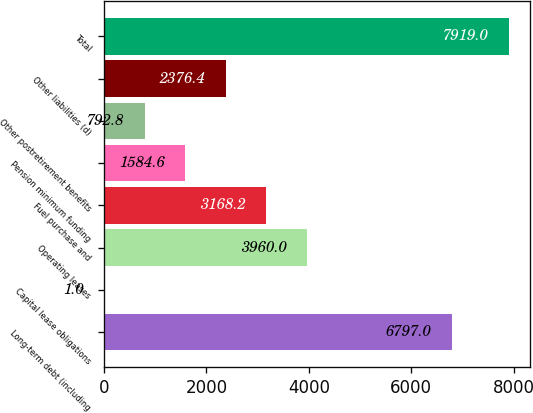<chart> <loc_0><loc_0><loc_500><loc_500><bar_chart><fcel>Long-term debt (including<fcel>Capital lease obligations<fcel>Operating leases<fcel>Fuel purchase and<fcel>Pension minimum funding<fcel>Other postretirement benefits<fcel>Other liabilities (d)<fcel>Total<nl><fcel>6797<fcel>1<fcel>3960<fcel>3168.2<fcel>1584.6<fcel>792.8<fcel>2376.4<fcel>7919<nl></chart> 